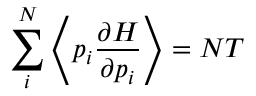Convert formula to latex. <formula><loc_0><loc_0><loc_500><loc_500>\sum _ { i } ^ { N } \left \langle p _ { i } \frac { \partial H } { \partial p _ { i } } \right \rangle = N T</formula> 